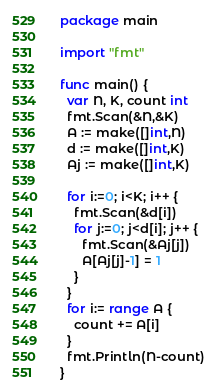Convert code to text. <code><loc_0><loc_0><loc_500><loc_500><_Go_>package main

import "fmt"

func main() {
  var N, K, count int
  fmt.Scan(&N,&K)
  A := make([]int,N)
  d := make([]int,K)
  Aj := make([]int,K)
  
  for i:=0; i<K; i++ {
    fmt.Scan(&d[i])
    for j:=0; j<d[i]; j++ {
      fmt.Scan(&Aj[j])
      A[Aj[j]-1] = 1
    }
  }
  for i:= range A {
    count += A[i]
  }
  fmt.Println(N-count)
}</code> 